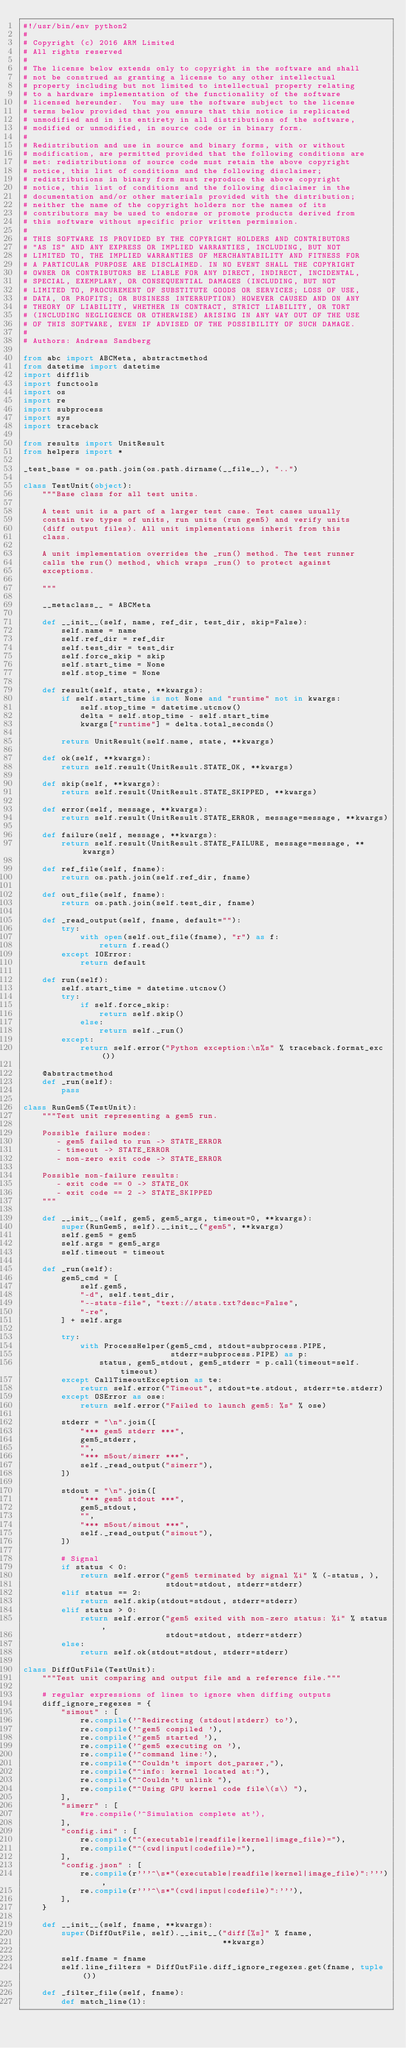<code> <loc_0><loc_0><loc_500><loc_500><_Python_>#!/usr/bin/env python2
#
# Copyright (c) 2016 ARM Limited
# All rights reserved
#
# The license below extends only to copyright in the software and shall
# not be construed as granting a license to any other intellectual
# property including but not limited to intellectual property relating
# to a hardware implementation of the functionality of the software
# licensed hereunder.  You may use the software subject to the license
# terms below provided that you ensure that this notice is replicated
# unmodified and in its entirety in all distributions of the software,
# modified or unmodified, in source code or in binary form.
#
# Redistribution and use in source and binary forms, with or without
# modification, are permitted provided that the following conditions are
# met: redistributions of source code must retain the above copyright
# notice, this list of conditions and the following disclaimer;
# redistributions in binary form must reproduce the above copyright
# notice, this list of conditions and the following disclaimer in the
# documentation and/or other materials provided with the distribution;
# neither the name of the copyright holders nor the names of its
# contributors may be used to endorse or promote products derived from
# this software without specific prior written permission.
#
# THIS SOFTWARE IS PROVIDED BY THE COPYRIGHT HOLDERS AND CONTRIBUTORS
# "AS IS" AND ANY EXPRESS OR IMPLIED WARRANTIES, INCLUDING, BUT NOT
# LIMITED TO, THE IMPLIED WARRANTIES OF MERCHANTABILITY AND FITNESS FOR
# A PARTICULAR PURPOSE ARE DISCLAIMED. IN NO EVENT SHALL THE COPYRIGHT
# OWNER OR CONTRIBUTORS BE LIABLE FOR ANY DIRECT, INDIRECT, INCIDENTAL,
# SPECIAL, EXEMPLARY, OR CONSEQUENTIAL DAMAGES (INCLUDING, BUT NOT
# LIMITED TO, PROCUREMENT OF SUBSTITUTE GOODS OR SERVICES; LOSS OF USE,
# DATA, OR PROFITS; OR BUSINESS INTERRUPTION) HOWEVER CAUSED AND ON ANY
# THEORY OF LIABILITY, WHETHER IN CONTRACT, STRICT LIABILITY, OR TORT
# (INCLUDING NEGLIGENCE OR OTHERWISE) ARISING IN ANY WAY OUT OF THE USE
# OF THIS SOFTWARE, EVEN IF ADVISED OF THE POSSIBILITY OF SUCH DAMAGE.
#
# Authors: Andreas Sandberg

from abc import ABCMeta, abstractmethod
from datetime import datetime
import difflib
import functools
import os
import re
import subprocess
import sys
import traceback

from results import UnitResult
from helpers import *

_test_base = os.path.join(os.path.dirname(__file__), "..")

class TestUnit(object):
    """Base class for all test units.

    A test unit is a part of a larger test case. Test cases usually
    contain two types of units, run units (run gem5) and verify units
    (diff output files). All unit implementations inherit from this
    class.

    A unit implementation overrides the _run() method. The test runner
    calls the run() method, which wraps _run() to protect against
    exceptions.

    """

    __metaclass__ = ABCMeta

    def __init__(self, name, ref_dir, test_dir, skip=False):
        self.name = name
        self.ref_dir = ref_dir
        self.test_dir = test_dir
        self.force_skip = skip
        self.start_time = None
        self.stop_time = None

    def result(self, state, **kwargs):
        if self.start_time is not None and "runtime" not in kwargs:
            self.stop_time = datetime.utcnow()
            delta = self.stop_time - self.start_time
            kwargs["runtime"] = delta.total_seconds()

        return UnitResult(self.name, state, **kwargs)

    def ok(self, **kwargs):
        return self.result(UnitResult.STATE_OK, **kwargs)

    def skip(self, **kwargs):
        return self.result(UnitResult.STATE_SKIPPED, **kwargs)

    def error(self, message, **kwargs):
        return self.result(UnitResult.STATE_ERROR, message=message, **kwargs)

    def failure(self, message, **kwargs):
        return self.result(UnitResult.STATE_FAILURE, message=message, **kwargs)

    def ref_file(self, fname):
        return os.path.join(self.ref_dir, fname)

    def out_file(self, fname):
        return os.path.join(self.test_dir, fname)

    def _read_output(self, fname, default=""):
        try:
            with open(self.out_file(fname), "r") as f:
                return f.read()
        except IOError:
            return default

    def run(self):
        self.start_time = datetime.utcnow()
        try:
            if self.force_skip:
                return self.skip()
            else:
                return self._run()
        except:
            return self.error("Python exception:\n%s" % traceback.format_exc())

    @abstractmethod
    def _run(self):
        pass

class RunGem5(TestUnit):
    """Test unit representing a gem5 run.

    Possible failure modes:
       - gem5 failed to run -> STATE_ERROR
       - timeout -> STATE_ERROR
       - non-zero exit code -> STATE_ERROR

    Possible non-failure results:
       - exit code == 0 -> STATE_OK
       - exit code == 2 -> STATE_SKIPPED
    """

    def __init__(self, gem5, gem5_args, timeout=0, **kwargs):
        super(RunGem5, self).__init__("gem5", **kwargs)
        self.gem5 = gem5
        self.args = gem5_args
        self.timeout = timeout

    def _run(self):
        gem5_cmd = [
            self.gem5,
            "-d", self.test_dir,
            "--stats-file", "text://stats.txt?desc=False",
            "-re",
        ] + self.args

        try:
            with ProcessHelper(gem5_cmd, stdout=subprocess.PIPE,
                               stderr=subprocess.PIPE) as p:
                status, gem5_stdout, gem5_stderr = p.call(timeout=self.timeout)
        except CallTimeoutException as te:
            return self.error("Timeout", stdout=te.stdout, stderr=te.stderr)
        except OSError as ose:
            return self.error("Failed to launch gem5: %s" % ose)

        stderr = "\n".join([
            "*** gem5 stderr ***",
            gem5_stderr,
            "",
            "*** m5out/simerr ***",
            self._read_output("simerr"),
        ])

        stdout = "\n".join([
            "*** gem5 stdout ***",
            gem5_stdout,
            "",
            "*** m5out/simout ***",
            self._read_output("simout"),
        ])

        # Signal
        if status < 0:
            return self.error("gem5 terminated by signal %i" % (-status, ),
                              stdout=stdout, stderr=stderr)
        elif status == 2:
            return self.skip(stdout=stdout, stderr=stderr)
        elif status > 0:
            return self.error("gem5 exited with non-zero status: %i" % status,
                              stdout=stdout, stderr=stderr)
        else:
            return self.ok(stdout=stdout, stderr=stderr)

class DiffOutFile(TestUnit):
    """Test unit comparing and output file and a reference file."""

    # regular expressions of lines to ignore when diffing outputs
    diff_ignore_regexes = {
        "simout" : [
            re.compile('^Redirecting (stdout|stderr) to'),
            re.compile('^gem5 compiled '),
            re.compile('^gem5 started '),
            re.compile('^gem5 executing on '),
            re.compile('^command line:'),
            re.compile("^Couldn't import dot_parser,"),
            re.compile("^info: kernel located at:"),
            re.compile("^Couldn't unlink "),
            re.compile("^Using GPU kernel code file\(s\) "),
        ],
        "simerr" : [
            #re.compile('^Simulation complete at'),
        ],
        "config.ini" : [
            re.compile("^(executable|readfile|kernel|image_file)="),
            re.compile("^(cwd|input|codefile)="),
        ],
        "config.json" : [
            re.compile(r'''^\s*"(executable|readfile|kernel|image_file)":'''),
            re.compile(r'''^\s*"(cwd|input|codefile)":'''),
        ],
    }

    def __init__(self, fname, **kwargs):
        super(DiffOutFile, self).__init__("diff[%s]" % fname,
                                          **kwargs)

        self.fname = fname
        self.line_filters = DiffOutFile.diff_ignore_regexes.get(fname, tuple())

    def _filter_file(self, fname):
        def match_line(l):</code> 